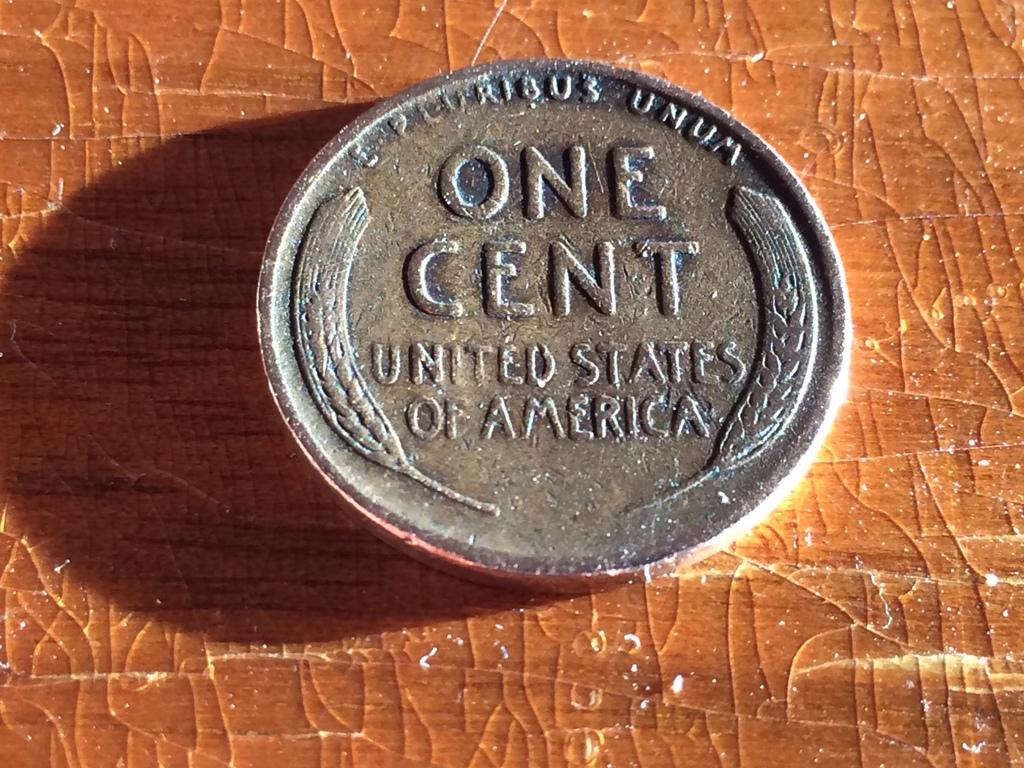Provide a one-sentence caption for the provided image. The back of the wheat penny reads, "E Pluribus Unum, One Cent, United States of America". 